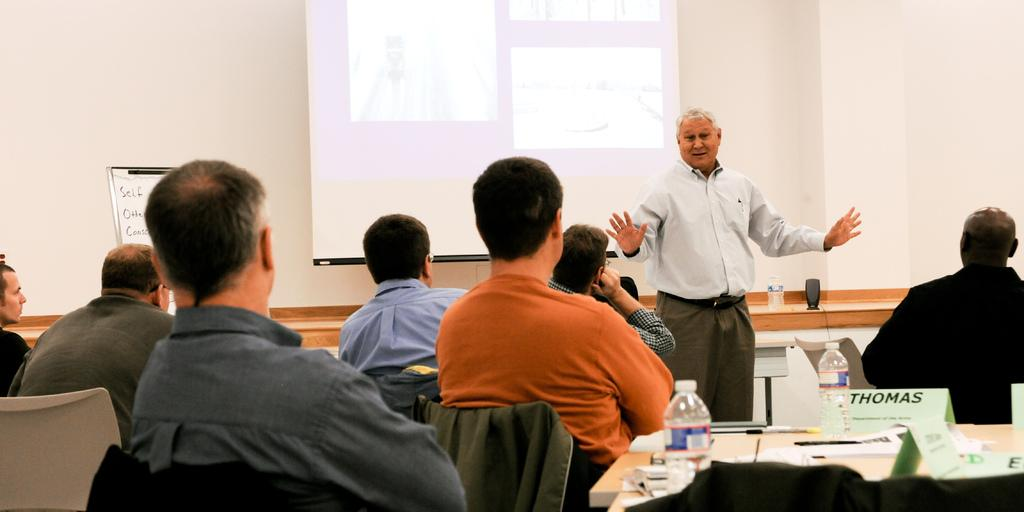What are the people in the image doing? People are sitting in the image. What is on the table in the image? There is a table in the image with bottles, paper, and name plates present. What is the purpose of the name plates on the table? The name plates on the table are likely used to identify the people sitting around it. What is the standing person in the image doing? There is a person standing in the image, but their specific action is not clear from the provided facts. What can be seen on the projector display in the image? The facts do not specify what is displayed on the projector, so we cannot answer this question definitively. What type of farm animals can be seen grazing in the image? There is no mention of a farm or any animals in the image; it features people sitting around a table with a projector display. 